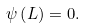Convert formula to latex. <formula><loc_0><loc_0><loc_500><loc_500>\psi \left ( L \right ) = 0 .</formula> 